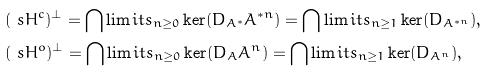Convert formula to latex. <formula><loc_0><loc_0><loc_500><loc_500>& ( \ s H ^ { c } ) ^ { \perp } = \bigcap \lim i t s _ { n \geq 0 } \ker ( D _ { A ^ { * } } A ^ { * n } ) = \bigcap \lim i t s _ { n \geq 1 } \ker ( D _ { A ^ { * n } } ) , \\ & ( \ s H ^ { o } ) ^ { \perp } = \bigcap \lim i t s _ { n \geq 0 } \ker ( D _ { A } A ^ { n } ) = \bigcap \lim i t s _ { n \geq 1 } \ker ( D _ { A ^ { n } } ) ,</formula> 